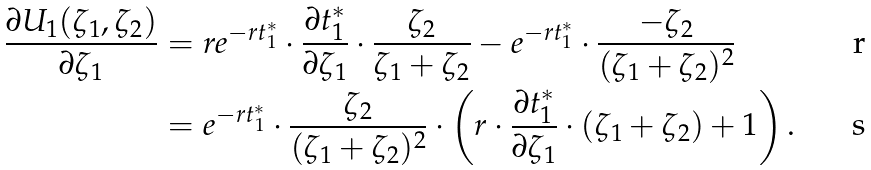<formula> <loc_0><loc_0><loc_500><loc_500>\frac { \partial U _ { 1 } ( \zeta _ { 1 } , \zeta _ { 2 } ) } { \partial \zeta _ { 1 } } & = r e ^ { - r t _ { 1 } ^ { * } } \cdot \frac { \partial t _ { 1 } ^ { * } } { \partial \zeta _ { 1 } } \cdot \frac { \zeta _ { 2 } } { \zeta _ { 1 } + \zeta _ { 2 } } - e ^ { - r t _ { 1 } ^ { * } } \cdot \frac { - \zeta _ { 2 } } { ( \zeta _ { 1 } + \zeta _ { 2 } ) ^ { 2 } } \\ & = e ^ { - r t _ { 1 } ^ { * } } \cdot \frac { \zeta _ { 2 } } { ( \zeta _ { 1 } + \zeta _ { 2 } ) ^ { 2 } } \cdot \left ( r \cdot \frac { \partial t _ { 1 } ^ { * } } { \partial \zeta _ { 1 } } \cdot ( \zeta _ { 1 } + \zeta _ { 2 } ) + 1 \right ) .</formula> 